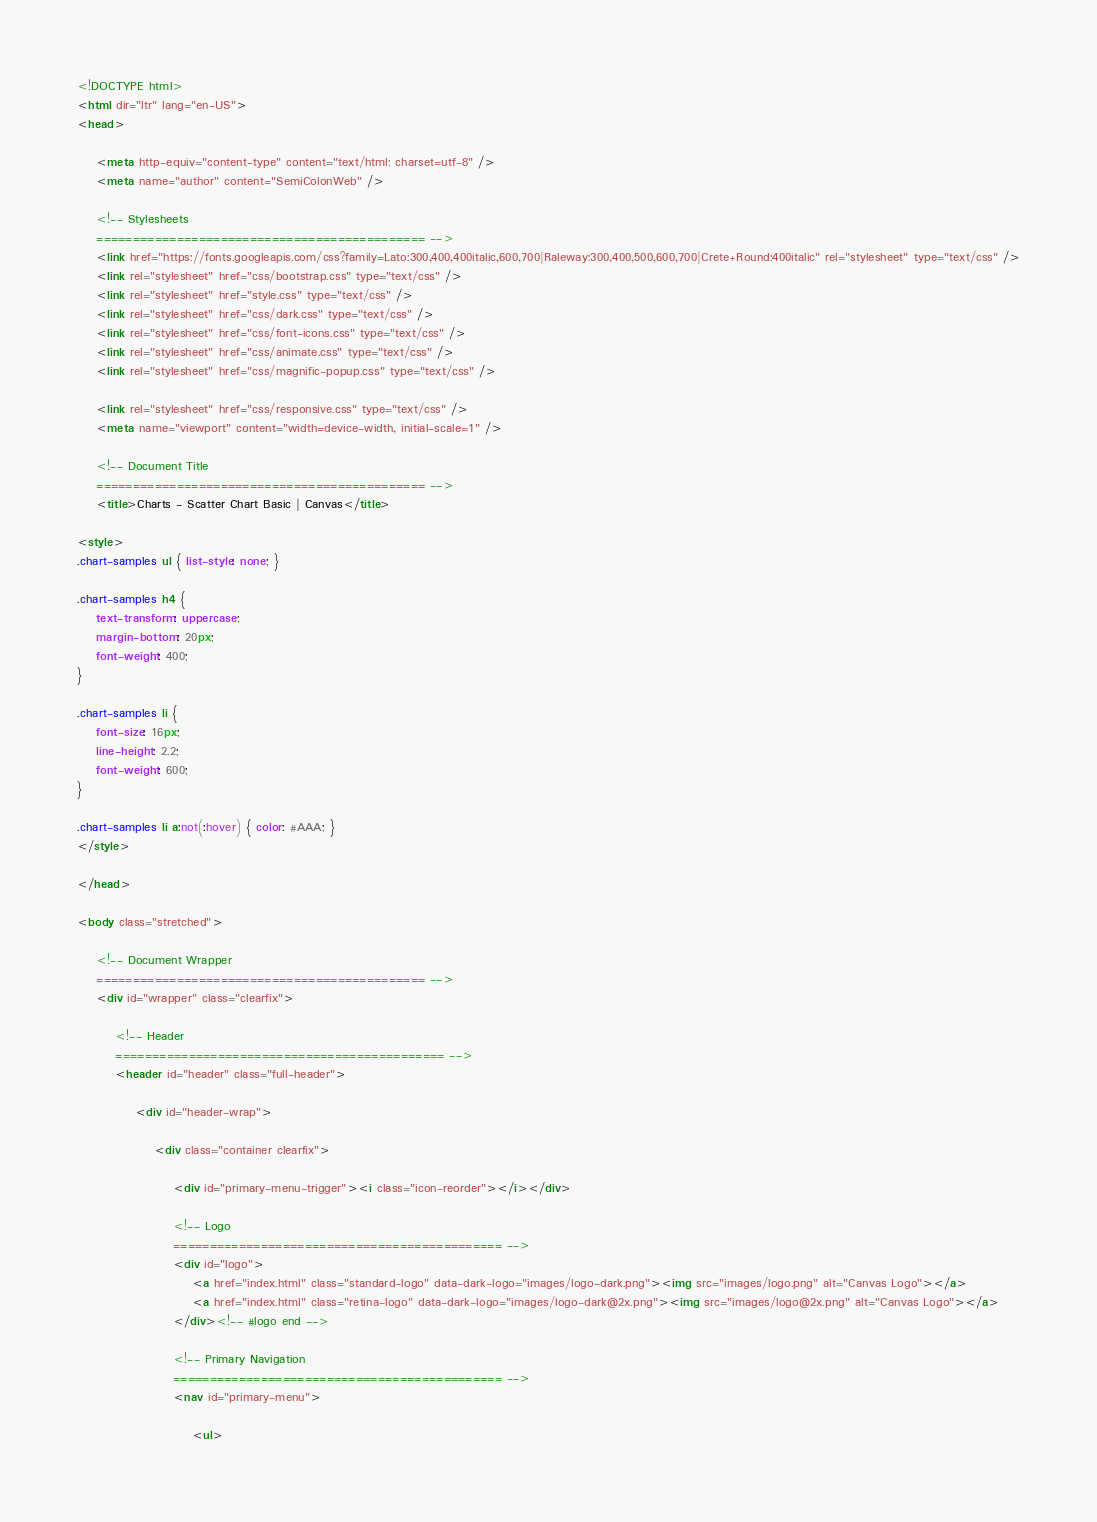<code> <loc_0><loc_0><loc_500><loc_500><_HTML_><!DOCTYPE html>
<html dir="ltr" lang="en-US">
<head>

	<meta http-equiv="content-type" content="text/html; charset=utf-8" />
	<meta name="author" content="SemiColonWeb" />

	<!-- Stylesheets
	============================================= -->
	<link href="https://fonts.googleapis.com/css?family=Lato:300,400,400italic,600,700|Raleway:300,400,500,600,700|Crete+Round:400italic" rel="stylesheet" type="text/css" />
	<link rel="stylesheet" href="css/bootstrap.css" type="text/css" />
	<link rel="stylesheet" href="style.css" type="text/css" />
	<link rel="stylesheet" href="css/dark.css" type="text/css" />
	<link rel="stylesheet" href="css/font-icons.css" type="text/css" />
	<link rel="stylesheet" href="css/animate.css" type="text/css" />
	<link rel="stylesheet" href="css/magnific-popup.css" type="text/css" />

	<link rel="stylesheet" href="css/responsive.css" type="text/css" />
	<meta name="viewport" content="width=device-width, initial-scale=1" />

	<!-- Document Title
	============================================= -->
	<title>Charts - Scatter Chart Basic | Canvas</title>

<style>
.chart-samples ul { list-style: none; }

.chart-samples h4 {
	text-transform: uppercase;
	margin-bottom: 20px;
	font-weight: 400;
}

.chart-samples li {
	font-size: 16px;
	line-height: 2.2;
	font-weight: 600;
}

.chart-samples li a:not(:hover) { color: #AAA; }
</style>

</head>

<body class="stretched">

	<!-- Document Wrapper
	============================================= -->
	<div id="wrapper" class="clearfix">

		<!-- Header
		============================================= -->
		<header id="header" class="full-header">

			<div id="header-wrap">

				<div class="container clearfix">

					<div id="primary-menu-trigger"><i class="icon-reorder"></i></div>

					<!-- Logo
					============================================= -->
					<div id="logo">
						<a href="index.html" class="standard-logo" data-dark-logo="images/logo-dark.png"><img src="images/logo.png" alt="Canvas Logo"></a>
						<a href="index.html" class="retina-logo" data-dark-logo="images/logo-dark@2x.png"><img src="images/logo@2x.png" alt="Canvas Logo"></a>
					</div><!-- #logo end -->

					<!-- Primary Navigation
					============================================= -->
					<nav id="primary-menu">

						<ul></code> 